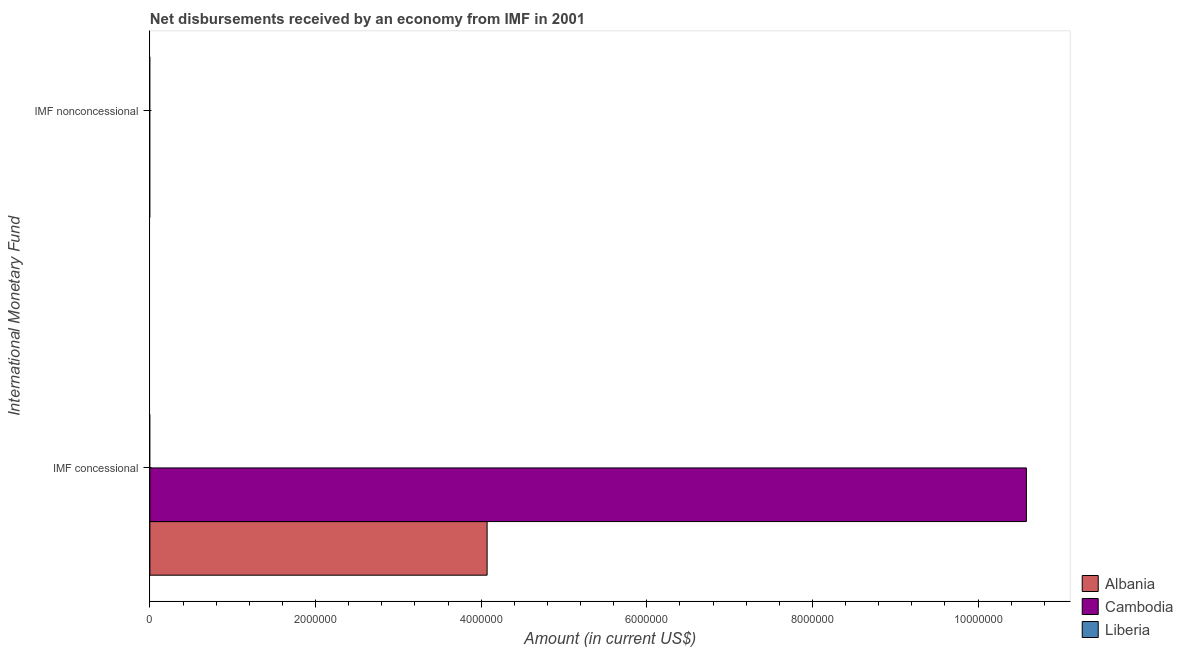How many different coloured bars are there?
Provide a short and direct response. 2. Are the number of bars per tick equal to the number of legend labels?
Ensure brevity in your answer.  No. How many bars are there on the 1st tick from the top?
Make the answer very short. 0. How many bars are there on the 2nd tick from the bottom?
Your answer should be compact. 0. What is the label of the 1st group of bars from the top?
Provide a short and direct response. IMF nonconcessional. Across all countries, what is the maximum net concessional disbursements from imf?
Your response must be concise. 1.06e+07. In which country was the net concessional disbursements from imf maximum?
Ensure brevity in your answer.  Cambodia. What is the total net concessional disbursements from imf in the graph?
Provide a succinct answer. 1.47e+07. What is the difference between the net concessional disbursements from imf in Cambodia and that in Albania?
Give a very brief answer. 6.51e+06. What is the average net concessional disbursements from imf per country?
Keep it short and to the point. 4.89e+06. What is the ratio of the net concessional disbursements from imf in Albania to that in Cambodia?
Ensure brevity in your answer.  0.38. In how many countries, is the net non concessional disbursements from imf greater than the average net non concessional disbursements from imf taken over all countries?
Provide a succinct answer. 0. How many bars are there?
Give a very brief answer. 2. How many countries are there in the graph?
Ensure brevity in your answer.  3. What is the difference between two consecutive major ticks on the X-axis?
Keep it short and to the point. 2.00e+06. Does the graph contain any zero values?
Provide a short and direct response. Yes. Does the graph contain grids?
Ensure brevity in your answer.  No. Where does the legend appear in the graph?
Keep it short and to the point. Bottom right. How many legend labels are there?
Your response must be concise. 3. How are the legend labels stacked?
Keep it short and to the point. Vertical. What is the title of the graph?
Provide a succinct answer. Net disbursements received by an economy from IMF in 2001. What is the label or title of the X-axis?
Offer a very short reply. Amount (in current US$). What is the label or title of the Y-axis?
Your response must be concise. International Monetary Fund. What is the Amount (in current US$) in Albania in IMF concessional?
Offer a terse response. 4.07e+06. What is the Amount (in current US$) in Cambodia in IMF concessional?
Your answer should be very brief. 1.06e+07. What is the Amount (in current US$) in Liberia in IMF nonconcessional?
Provide a short and direct response. 0. Across all International Monetary Fund, what is the maximum Amount (in current US$) in Albania?
Offer a very short reply. 4.07e+06. Across all International Monetary Fund, what is the maximum Amount (in current US$) of Cambodia?
Give a very brief answer. 1.06e+07. Across all International Monetary Fund, what is the minimum Amount (in current US$) in Cambodia?
Your answer should be very brief. 0. What is the total Amount (in current US$) in Albania in the graph?
Ensure brevity in your answer.  4.07e+06. What is the total Amount (in current US$) in Cambodia in the graph?
Make the answer very short. 1.06e+07. What is the average Amount (in current US$) of Albania per International Monetary Fund?
Give a very brief answer. 2.04e+06. What is the average Amount (in current US$) in Cambodia per International Monetary Fund?
Make the answer very short. 5.29e+06. What is the average Amount (in current US$) of Liberia per International Monetary Fund?
Provide a short and direct response. 0. What is the difference between the Amount (in current US$) in Albania and Amount (in current US$) in Cambodia in IMF concessional?
Ensure brevity in your answer.  -6.51e+06. What is the difference between the highest and the lowest Amount (in current US$) of Albania?
Ensure brevity in your answer.  4.07e+06. What is the difference between the highest and the lowest Amount (in current US$) in Cambodia?
Offer a terse response. 1.06e+07. 